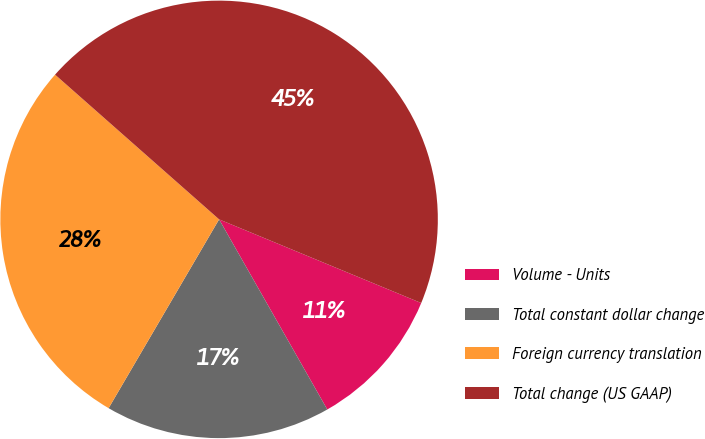Convert chart. <chart><loc_0><loc_0><loc_500><loc_500><pie_chart><fcel>Volume - Units<fcel>Total constant dollar change<fcel>Foreign currency translation<fcel>Total change (US GAAP)<nl><fcel>10.52%<fcel>16.66%<fcel>28.08%<fcel>44.74%<nl></chart> 